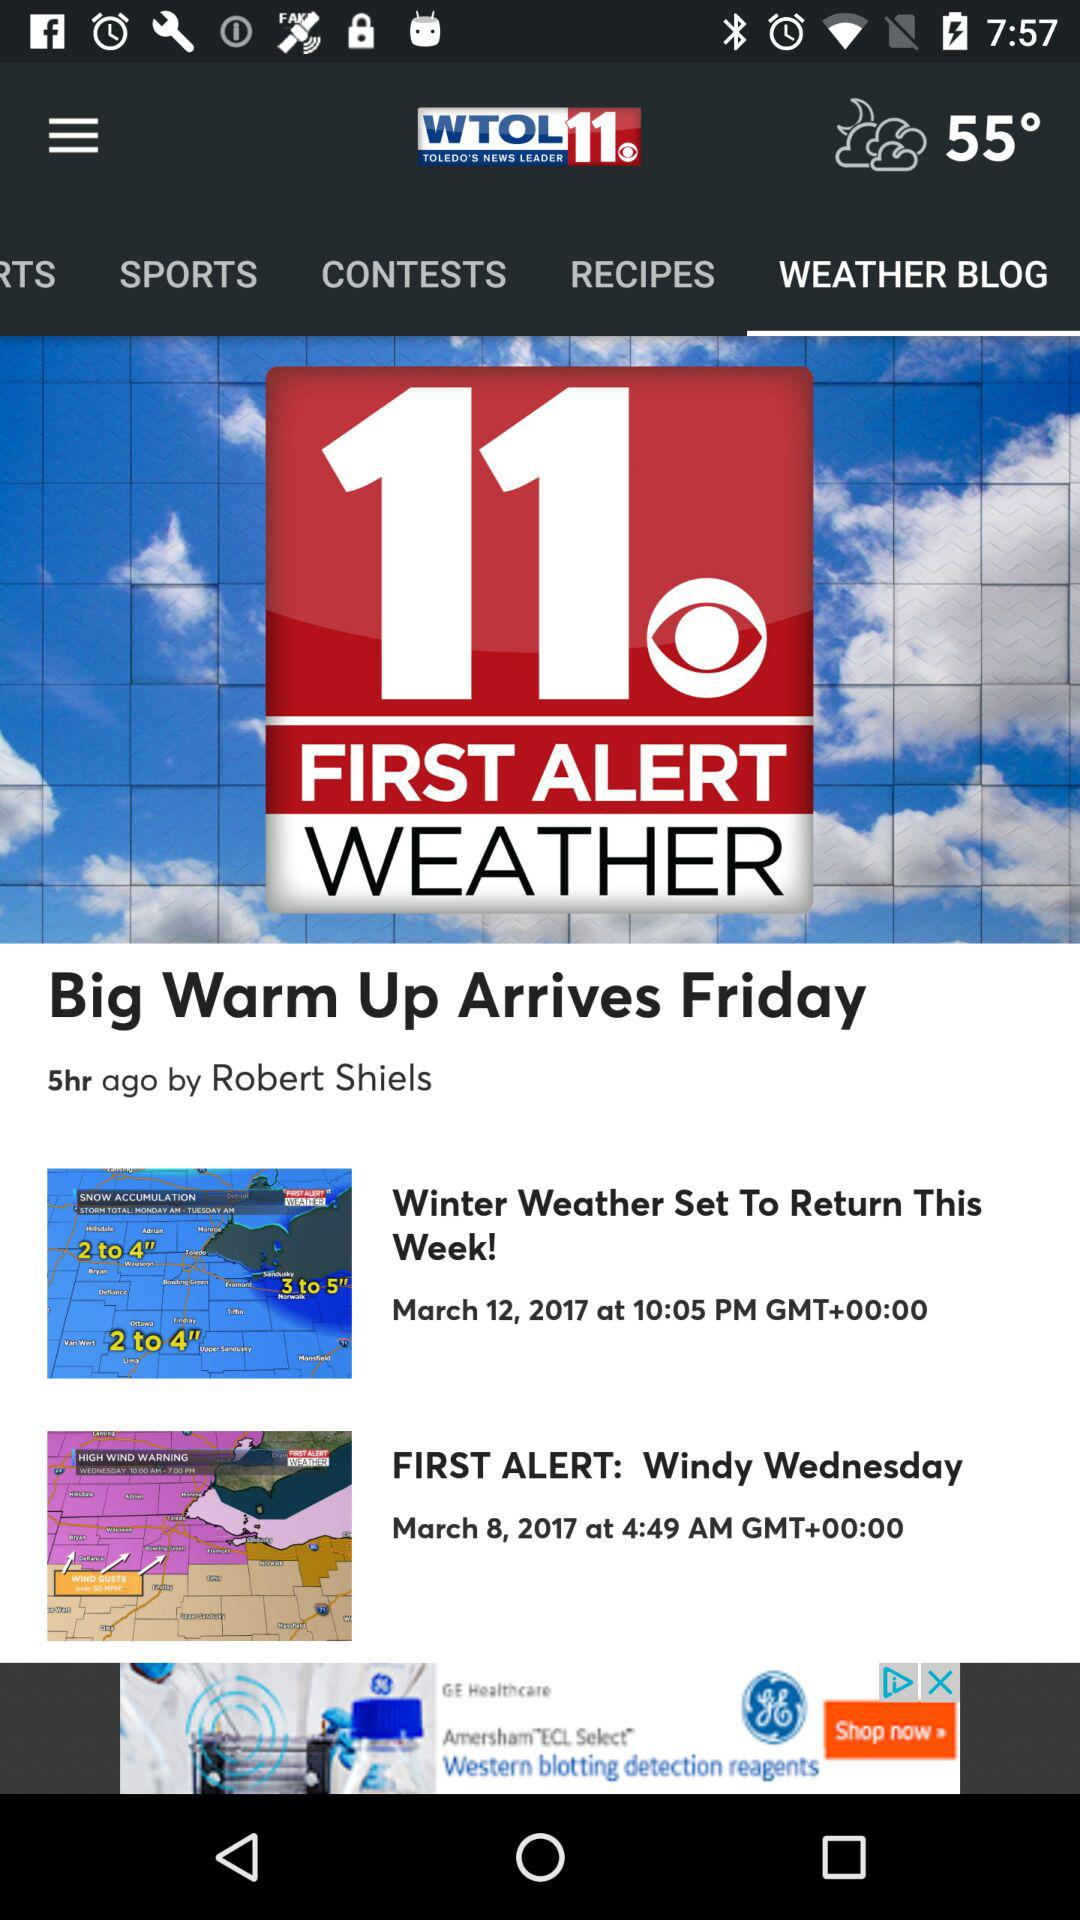What is the date of the "FIRST ALERT: Windy Wednesday"? The date is March 8, 2017. 